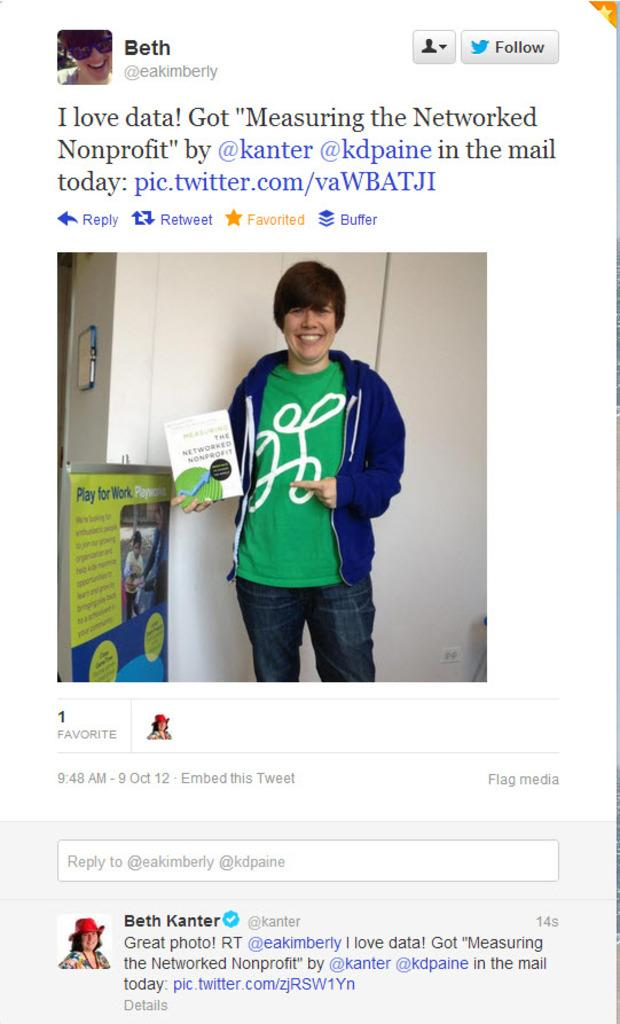<image>
Relay a brief, clear account of the picture shown. A twitter page of a twitter creator called Beth concerning a nonprofit. 